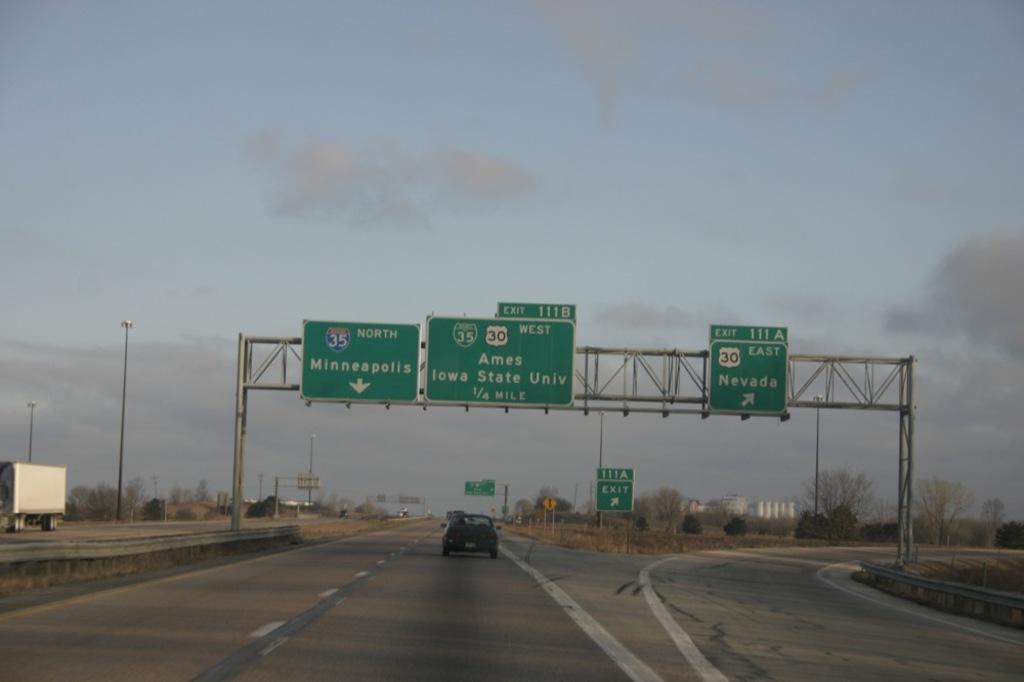Is the exit to nevada coming up?
Keep it short and to the point. Yes. What exit is on the right?
Provide a succinct answer. Nevada. 